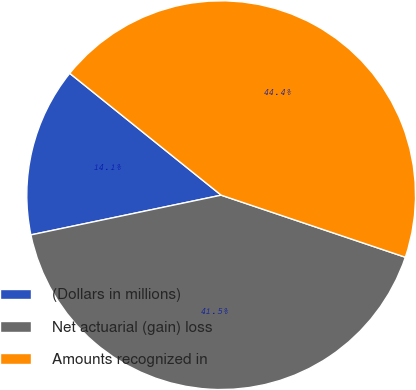<chart> <loc_0><loc_0><loc_500><loc_500><pie_chart><fcel>(Dollars in millions)<fcel>Net actuarial (gain) loss<fcel>Amounts recognized in<nl><fcel>14.06%<fcel>41.55%<fcel>44.39%<nl></chart> 